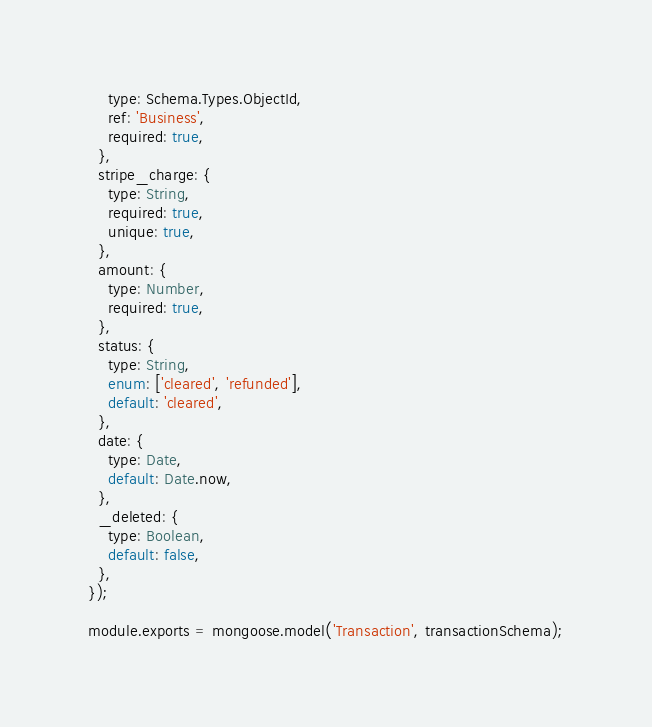<code> <loc_0><loc_0><loc_500><loc_500><_JavaScript_>    type: Schema.Types.ObjectId,
    ref: 'Business',
    required: true,
  },
  stripe_charge: {
    type: String,
    required: true,
    unique: true,
  },
  amount: {
    type: Number,
    required: true,
  },
  status: {
    type: String,
    enum: ['cleared', 'refunded'],
    default: 'cleared',
  },
  date: {
    type: Date,
    default: Date.now,
  },
  _deleted: {
    type: Boolean,
    default: false,
  },
});

module.exports = mongoose.model('Transaction', transactionSchema);
</code> 